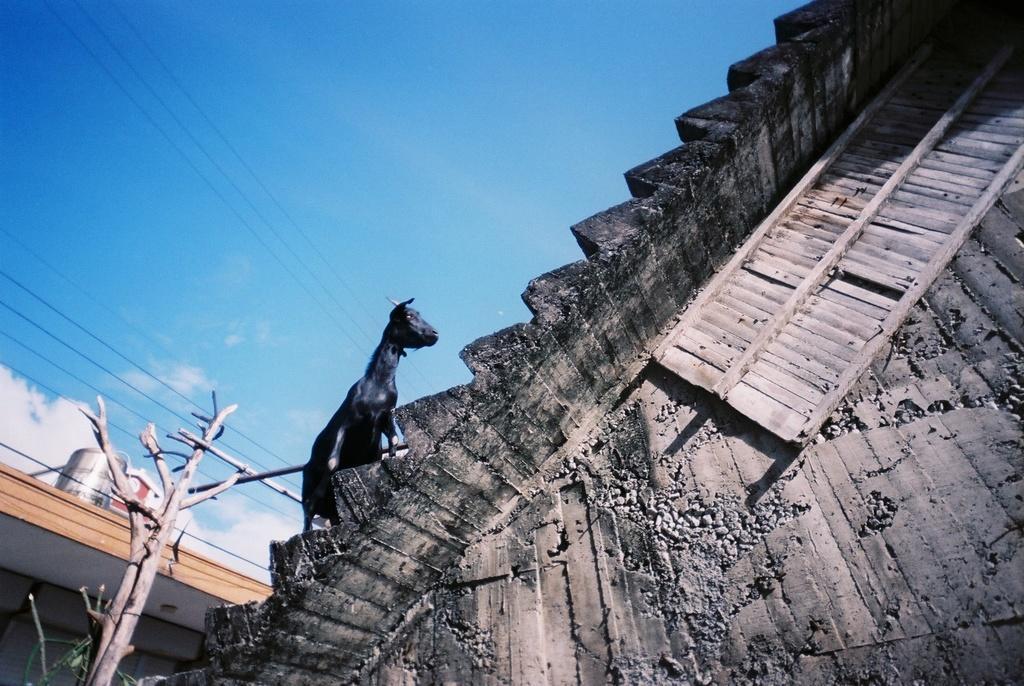Please provide a concise description of this image. In this image we can see steps. On the steps there is an animal. Also there is a wooden object. On the left side there is a tree. Also we can see sky with clouds and few other objects. 